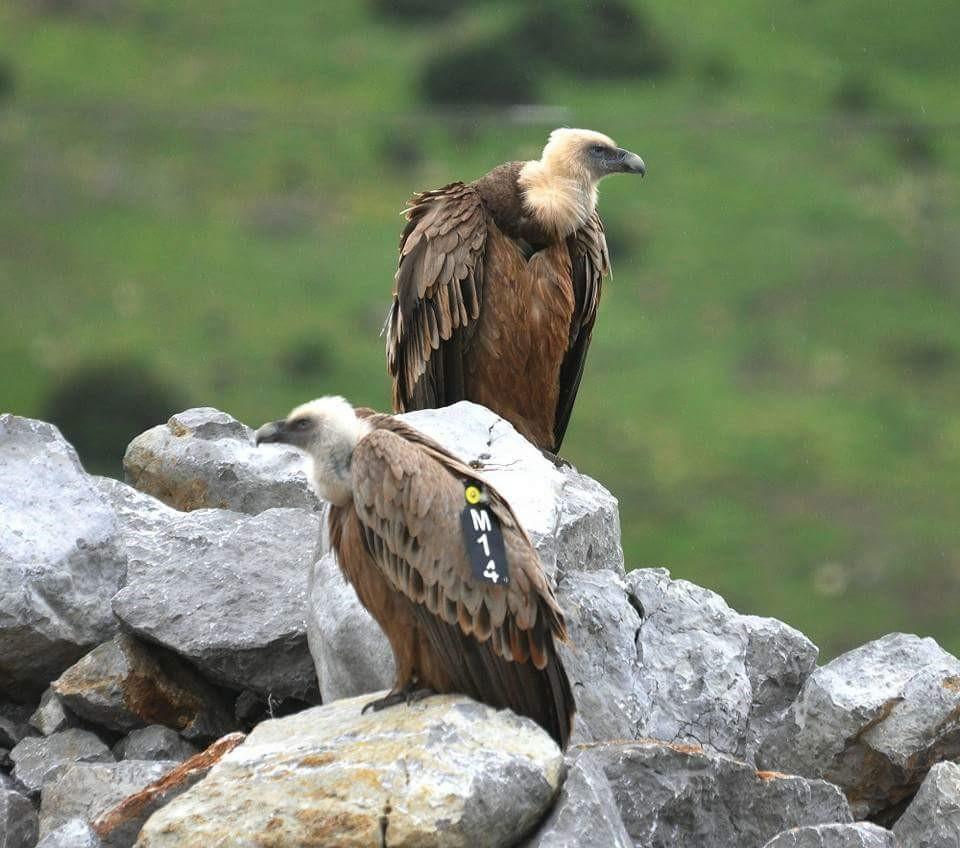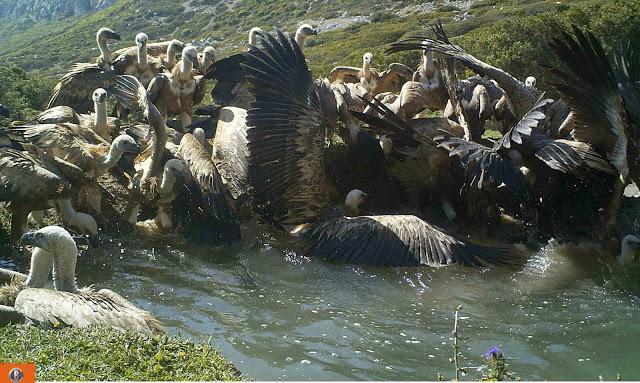The first image is the image on the left, the second image is the image on the right. Considering the images on both sides, is "a vulture has a tag on its left wing" valid? Answer yes or no. Yes. 